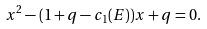Convert formula to latex. <formula><loc_0><loc_0><loc_500><loc_500>x ^ { 2 } - ( 1 + q - c _ { 1 } ( E ) ) x + q = 0 .</formula> 